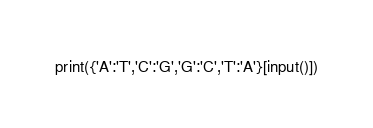<code> <loc_0><loc_0><loc_500><loc_500><_Python_>print({'A':'T','C':'G','G':'C','T':'A'}[input()])
</code> 